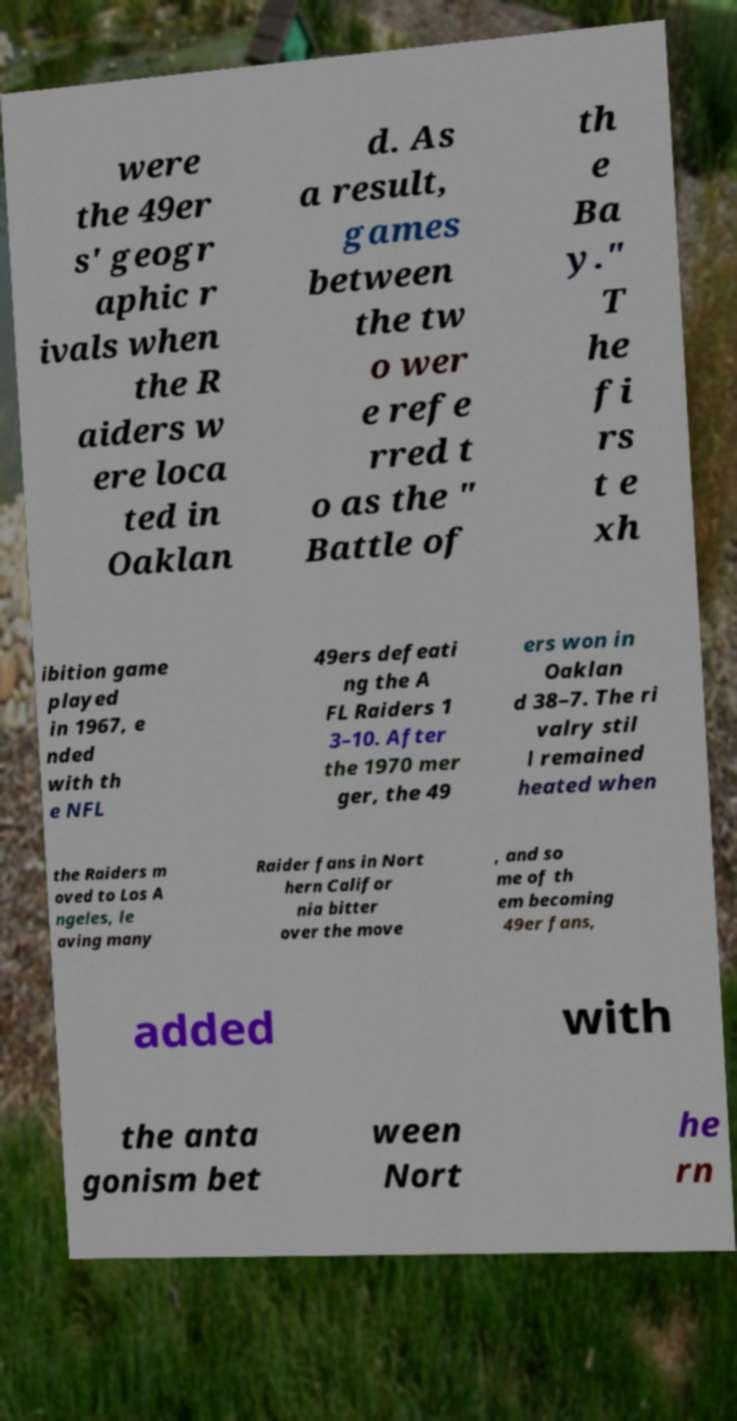Can you read and provide the text displayed in the image?This photo seems to have some interesting text. Can you extract and type it out for me? were the 49er s' geogr aphic r ivals when the R aiders w ere loca ted in Oaklan d. As a result, games between the tw o wer e refe rred t o as the " Battle of th e Ba y." T he fi rs t e xh ibition game played in 1967, e nded with th e NFL 49ers defeati ng the A FL Raiders 1 3–10. After the 1970 mer ger, the 49 ers won in Oaklan d 38–7. The ri valry stil l remained heated when the Raiders m oved to Los A ngeles, le aving many Raider fans in Nort hern Califor nia bitter over the move , and so me of th em becoming 49er fans, added with the anta gonism bet ween Nort he rn 